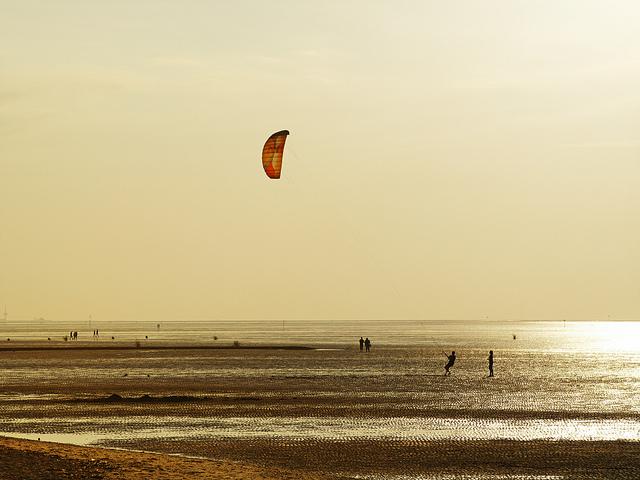Is this at the mountains?
Concise answer only. No. Is the kite high?
Be succinct. Yes. Are the people standing in water?
Write a very short answer. Yes. How many kites have a checkered pattern?
Be succinct. 1. How many people are holding onto the parachute line?
Write a very short answer. 1. 